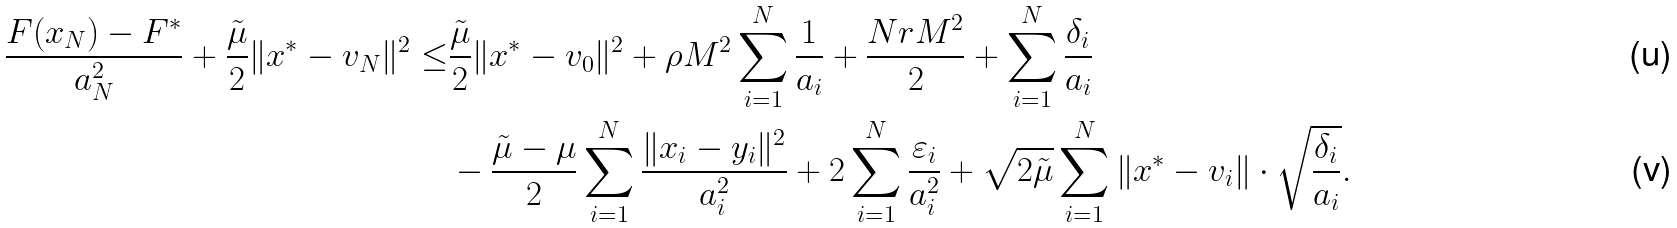<formula> <loc_0><loc_0><loc_500><loc_500>\frac { F ( x _ { N } ) - F ^ { * } } { a _ { N } ^ { 2 } } + \frac { \tilde { \mu } } { 2 } \| x ^ { * } - v _ { N } \| ^ { 2 } \leq & \frac { \tilde { \mu } } { 2 } \| x ^ { * } - v _ { 0 } \| ^ { 2 } + \rho M ^ { 2 } \sum _ { i = 1 } ^ { N } \frac { 1 } { a _ { i } } + \frac { N r M ^ { 2 } } { 2 } + \sum ^ { N } _ { i = 1 } \frac { \delta _ { i } } { a _ { i } } \\ & - \frac { \tilde { \mu } - \mu } { 2 } \sum _ { i = 1 } ^ { N } \frac { \| x _ { i } - y _ { i } \| ^ { 2 } } { a _ { i } ^ { 2 } } + 2 \sum _ { i = 1 } ^ { N } \frac { \varepsilon _ { i } } { a _ { i } ^ { 2 } } + \sqrt { 2 \tilde { \mu } } \sum _ { i = 1 } ^ { N } \| x ^ { * } - v _ { i } \| \cdot \sqrt { \frac { \delta _ { i } } { a _ { i } } } .</formula> 